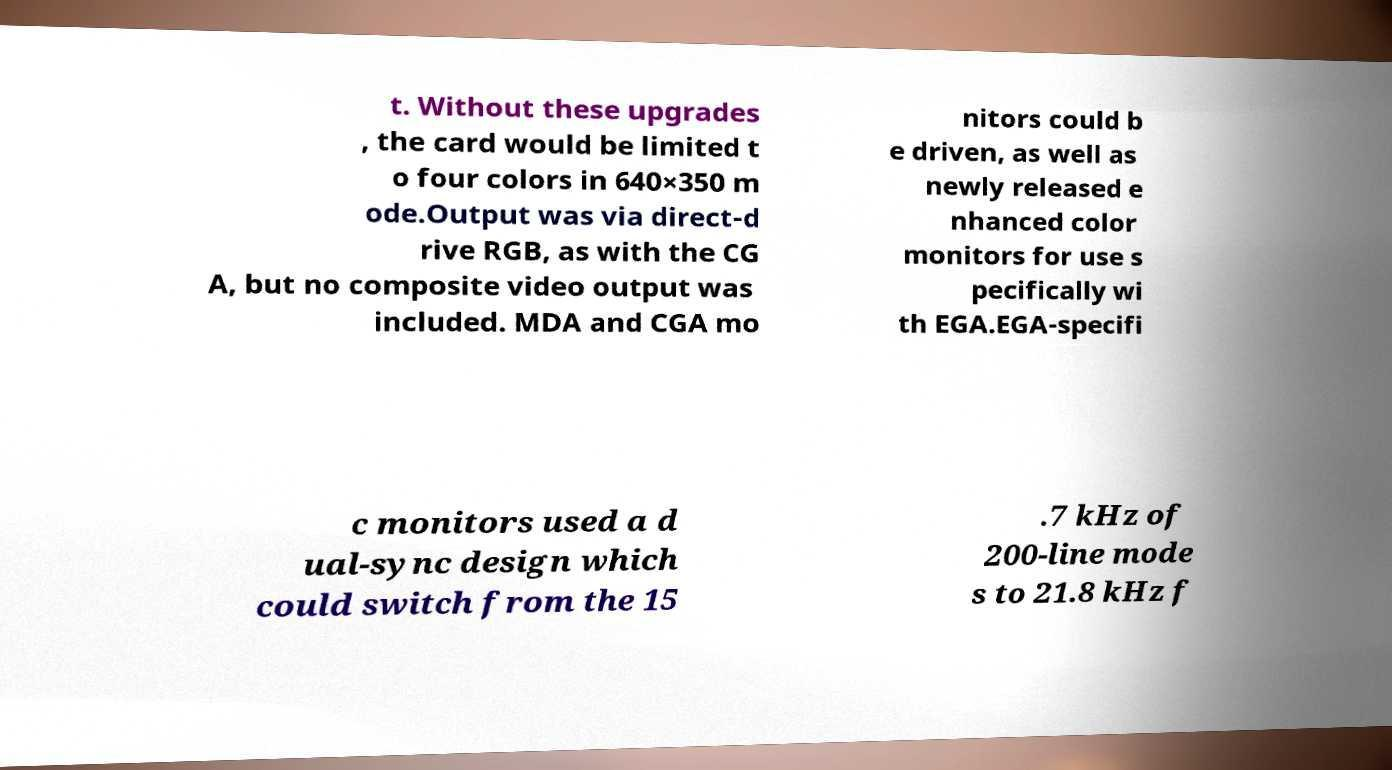I need the written content from this picture converted into text. Can you do that? t. Without these upgrades , the card would be limited t o four colors in 640×350 m ode.Output was via direct-d rive RGB, as with the CG A, but no composite video output was included. MDA and CGA mo nitors could b e driven, as well as newly released e nhanced color monitors for use s pecifically wi th EGA.EGA-specifi c monitors used a d ual-sync design which could switch from the 15 .7 kHz of 200-line mode s to 21.8 kHz f 